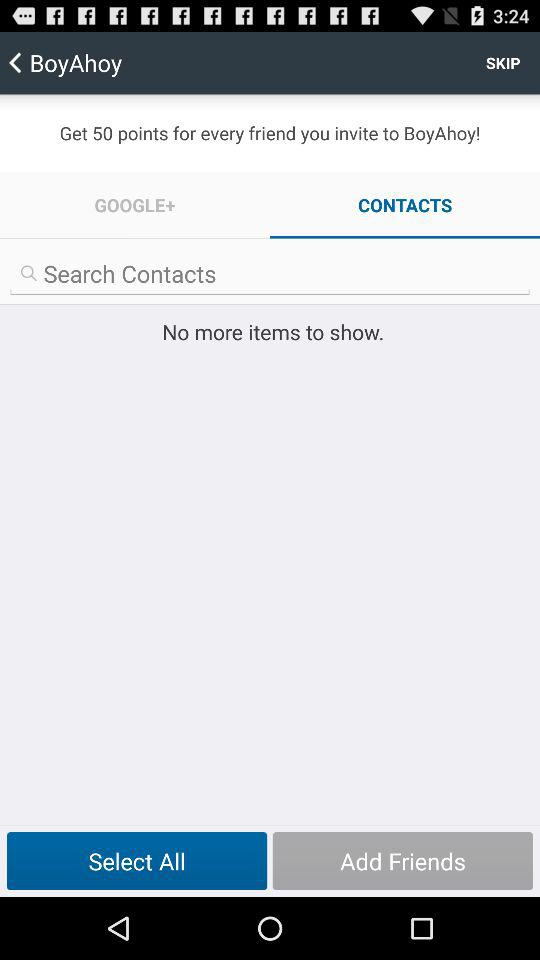What is the name of the application? The name of the application is "BoyAhoy". 